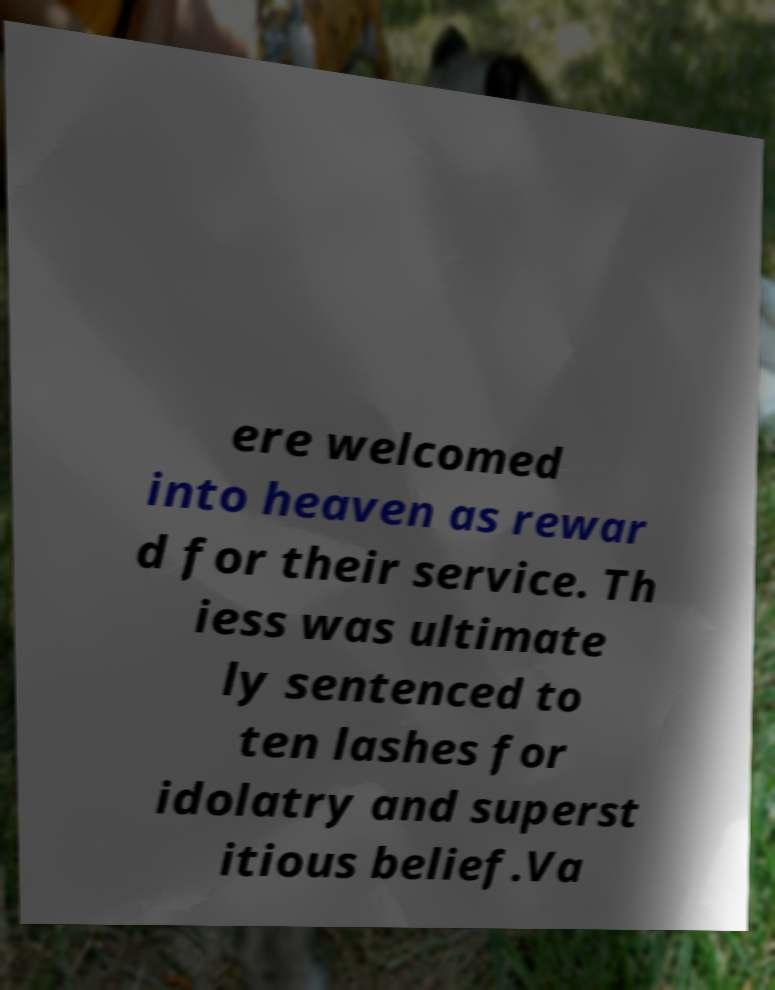Could you assist in decoding the text presented in this image and type it out clearly? ere welcomed into heaven as rewar d for their service. Th iess was ultimate ly sentenced to ten lashes for idolatry and superst itious belief.Va 